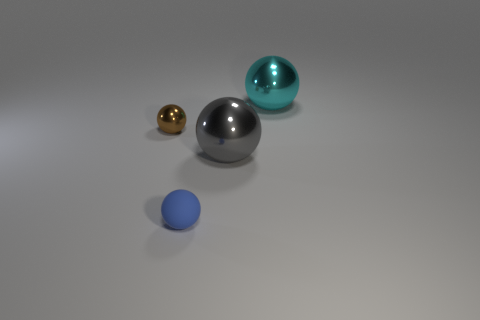Is the brown shiny sphere the same size as the rubber sphere?
Provide a short and direct response. Yes. How many things are either small brown shiny spheres that are behind the gray metallic object or tiny things that are in front of the small brown metal ball?
Provide a short and direct response. 2. How many small metallic balls are right of the large metal sphere behind the large shiny thing that is to the left of the cyan shiny ball?
Offer a very short reply. 0. How big is the metallic sphere in front of the brown metal sphere?
Your response must be concise. Large. How many other metallic objects have the same size as the gray shiny thing?
Provide a succinct answer. 1. Do the cyan metal sphere and the blue thing right of the tiny brown ball have the same size?
Provide a short and direct response. No. How many things are either blue cylinders or brown metal things?
Keep it short and to the point. 1. How many other matte balls have the same color as the tiny matte sphere?
Your answer should be very brief. 0. Are there any tiny blue metal things that have the same shape as the large gray shiny thing?
Provide a succinct answer. No. What number of blue spheres have the same material as the small brown sphere?
Keep it short and to the point. 0. 